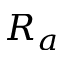Convert formula to latex. <formula><loc_0><loc_0><loc_500><loc_500>R _ { a }</formula> 